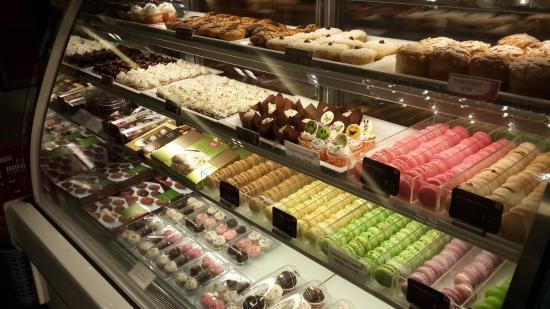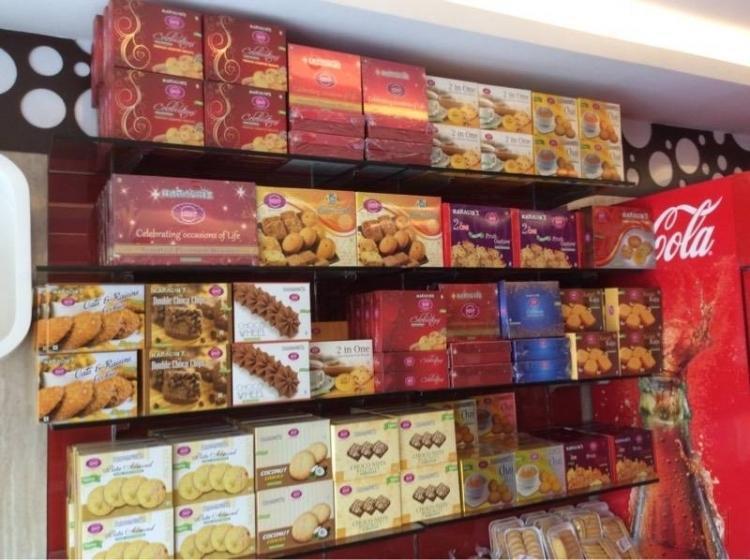The first image is the image on the left, the second image is the image on the right. For the images displayed, is the sentence "There is at least one person in front of a store in the right image." factually correct? Answer yes or no. No. The first image is the image on the left, the second image is the image on the right. Considering the images on both sides, is "There is a four tier desert case that houses cholate desserts and breads." valid? Answer yes or no. Yes. 